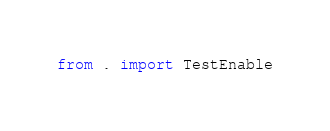Convert code to text. <code><loc_0><loc_0><loc_500><loc_500><_Python_>from . import TestEnable</code> 